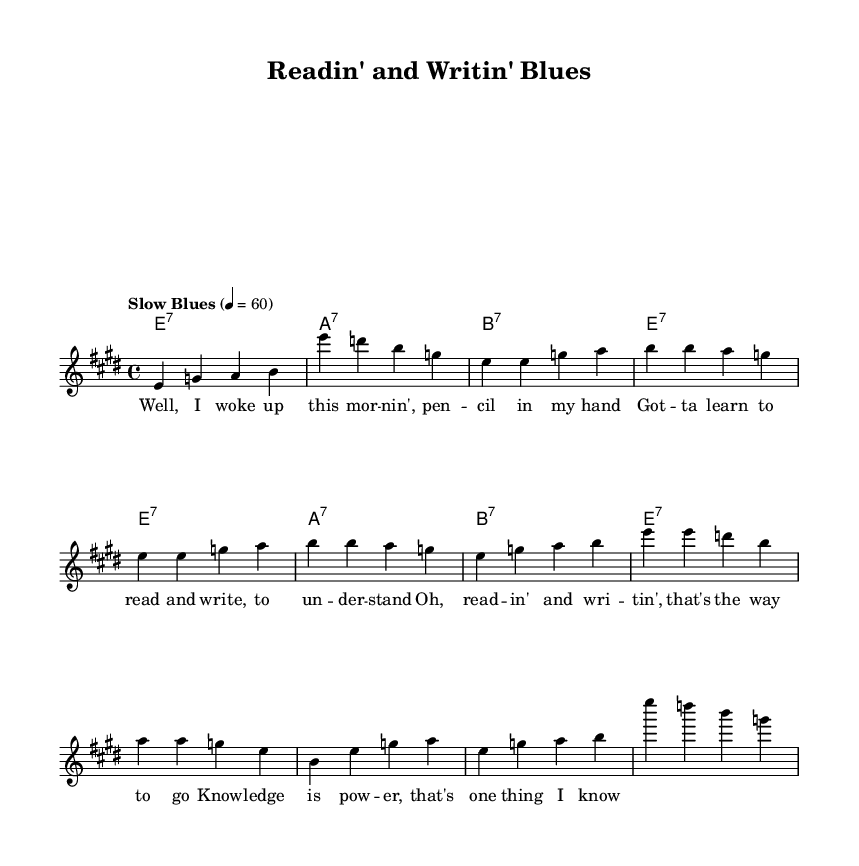What is the key signature of this music? The key signature is indicated at the beginning of the piece, showing that there are four sharps, which is characteristic of E major.
Answer: E major What is the time signature of this music? The time signature is shown at the beginning of the piece as 4/4, meaning there are four beats in each measure.
Answer: 4/4 What is the tempo marking of this music? The tempo marking "Slow Blues" is stated above the staff, indicating the intended speed and feel of the piece.
Answer: Slow Blues How many verses are in the song? The song contains one verse, which can be identified in the lyrics section of the sheet music.
Answer: One What type of chords are used in the harmony? The chords are labeled as 7th chords, common in blues music, which can be seen in the chord changes shown throughout the piece.
Answer: 7th chords What is the primary theme of the lyrics? The lyrics emphasize the importance of education, mentioning reading and writing as key elements of knowledge.
Answer: Education Which section of the music features the outro? The outro consists of material that resembles the intro, as indicated by the repetition of the introductory melody notes.
Answer: Intro material 